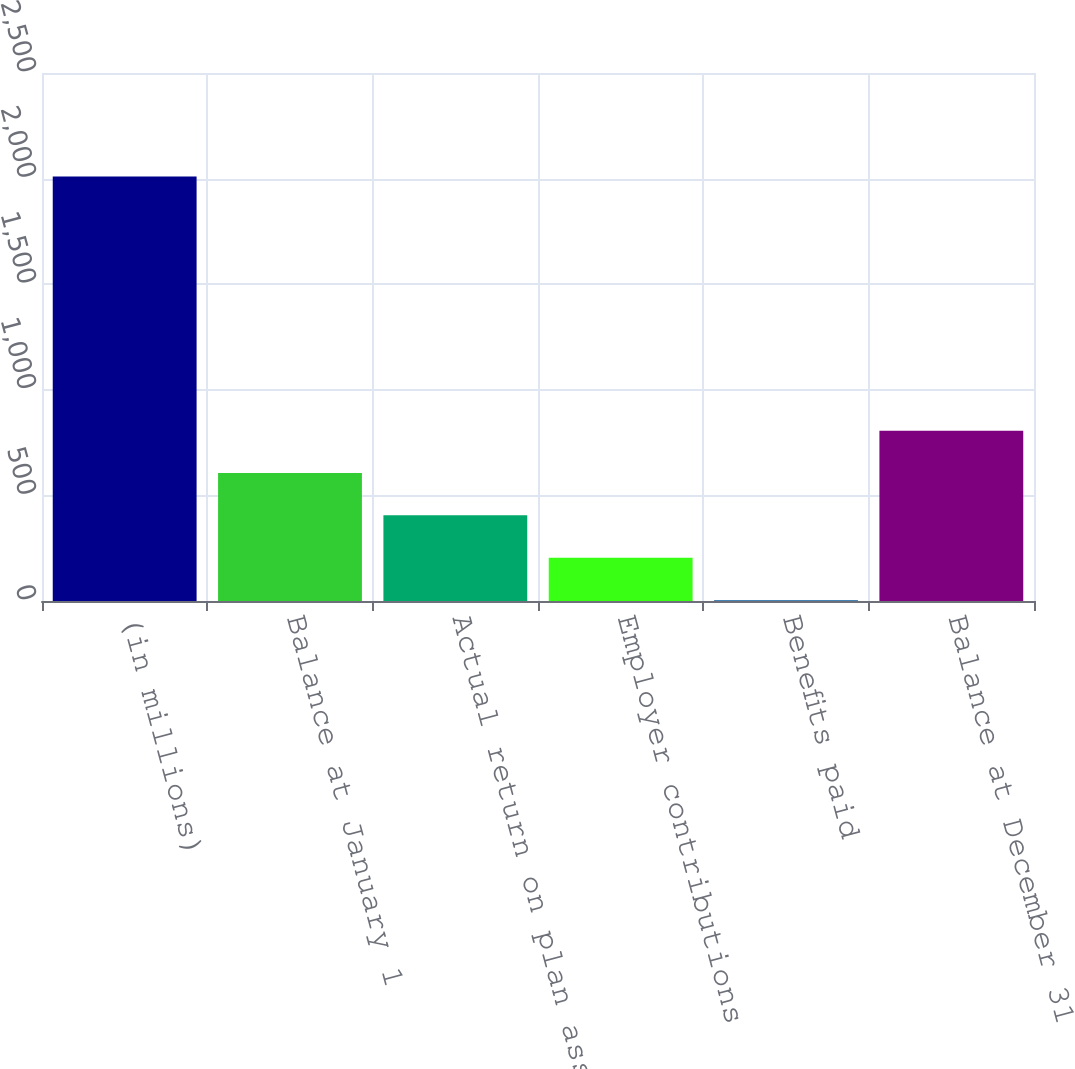Convert chart to OTSL. <chart><loc_0><loc_0><loc_500><loc_500><bar_chart><fcel>(in millions)<fcel>Balance at January 1<fcel>Actual return on plan assets<fcel>Employer contributions<fcel>Benefits paid<fcel>Balance at December 31<nl><fcel>2010<fcel>606.08<fcel>405.52<fcel>204.96<fcel>4.4<fcel>806.64<nl></chart> 